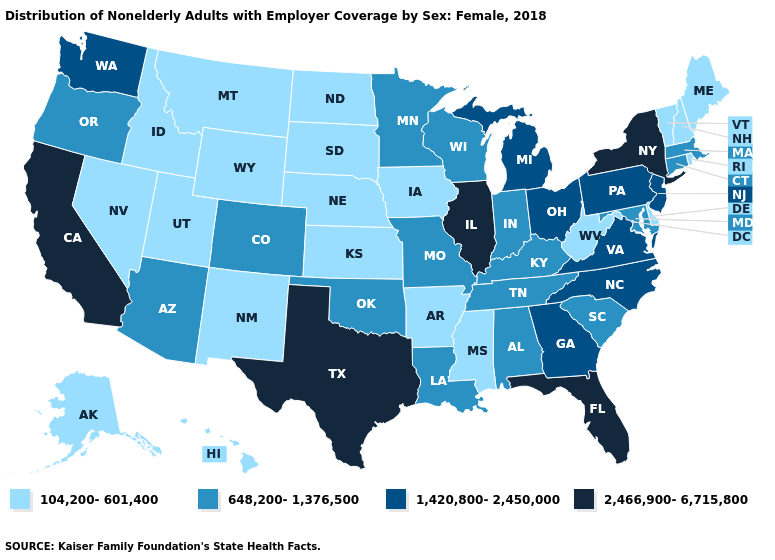Among the states that border Minnesota , which have the lowest value?
Short answer required. Iowa, North Dakota, South Dakota. Does Montana have the lowest value in the West?
Give a very brief answer. Yes. What is the highest value in the USA?
Be succinct. 2,466,900-6,715,800. Which states hav the highest value in the Northeast?
Answer briefly. New York. Among the states that border Indiana , does Michigan have the highest value?
Write a very short answer. No. Name the states that have a value in the range 104,200-601,400?
Keep it brief. Alaska, Arkansas, Delaware, Hawaii, Idaho, Iowa, Kansas, Maine, Mississippi, Montana, Nebraska, Nevada, New Hampshire, New Mexico, North Dakota, Rhode Island, South Dakota, Utah, Vermont, West Virginia, Wyoming. Does the first symbol in the legend represent the smallest category?
Concise answer only. Yes. What is the lowest value in states that border Florida?
Short answer required. 648,200-1,376,500. Does Rhode Island have the lowest value in the Northeast?
Write a very short answer. Yes. Name the states that have a value in the range 2,466,900-6,715,800?
Write a very short answer. California, Florida, Illinois, New York, Texas. Does New Jersey have a higher value than Illinois?
Give a very brief answer. No. Name the states that have a value in the range 1,420,800-2,450,000?
Keep it brief. Georgia, Michigan, New Jersey, North Carolina, Ohio, Pennsylvania, Virginia, Washington. What is the highest value in the MidWest ?
Quick response, please. 2,466,900-6,715,800. Among the states that border South Dakota , does Minnesota have the highest value?
Give a very brief answer. Yes. 